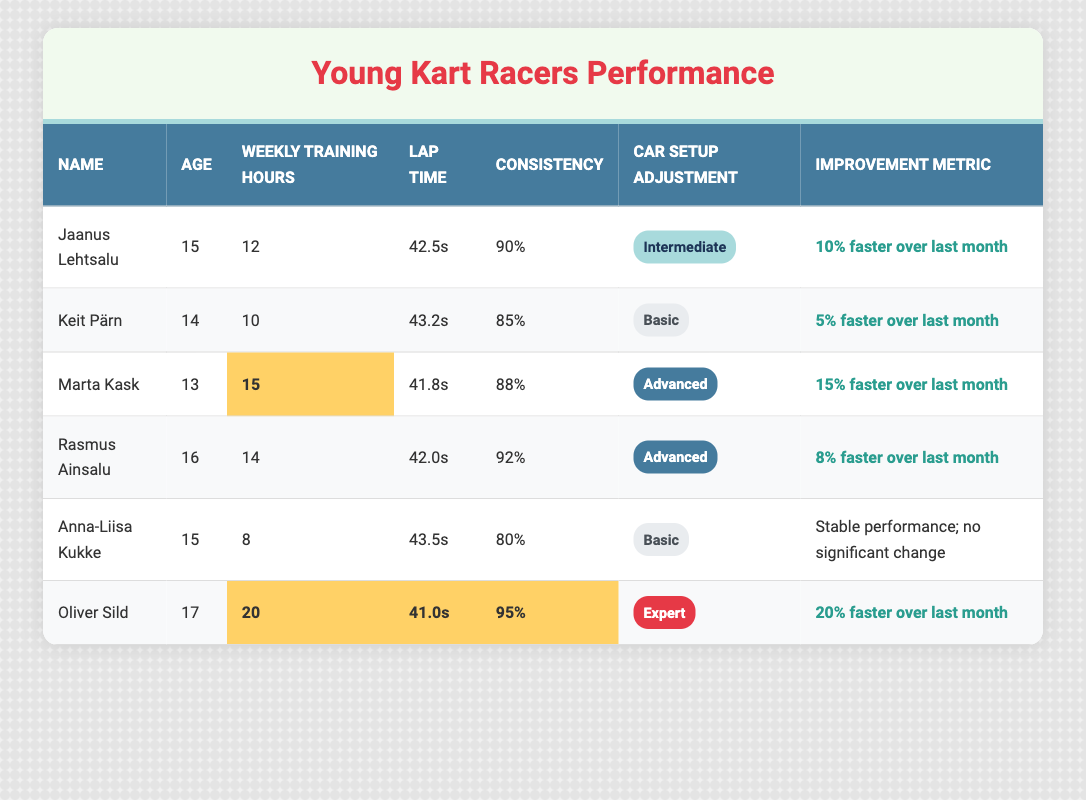What's the lap time of Jaanus Lehtsalu? Looking at the table, Jaanus Lehtsalu's lap time is listed as 42.5 seconds.
Answer: 42.5s Which kart racer has the highest weekly training hours? From the data in the table, Oliver Sild has the highest weekly training hours at 20 hours.
Answer: Oliver Sild How much faster is Marta Kask compared to Keit Pärn? Marta Kask's lap time is 41.8 seconds, while Keit Pärn's is 43.2 seconds. The difference is 43.2 - 41.8 = 1.4 seconds, meaning Marta is 1.4 seconds faster.
Answer: 1.4 seconds Who has the lowest consistency percentage? Anna-Liisa Kukke has the lowest consistency percentage at 80%, as seen in the comparison of the percentages in the table.
Answer: 80% Is Oliver Sild improving faster than Rasmus Ainsalu? Oliver Sild's improvement metric indicates he is 20% faster over last month, while Rasmus Ainsalu's metric shows he is 8% faster. Since 20% is greater than 8%, Oliver is improving faster.
Answer: Yes What is the average lap time of all listed racers? To find the average lap time, we need to sum the lap times: 42.5 + 43.2 + 41.8 + 42.0 + 43.5 + 41.0 = 254 seconds, then divide by the number of racers (6). So, 254 / 6 = 42.33 seconds average lap time.
Answer: 42.33s How many racers have more than 10 weekly training hours? The racers with more than 10 weekly training hours are Jaanus Lehtsalu, Marta Kask, Rasmus Ainsalu, and Oliver Sild - totaling 4 racers.
Answer: 4 What improvements have racers with 'Advanced' car setup adjustments made? Marta Kask has improved by 15%, and Rasmus Ainsalu has improved by 8%. The average of their improvements is (15% + 8%) / 2 = 11.5%.
Answer: 11.5% Who has shown stable performance with no significant change? The table indicates that Anna-Liisa Kukke reported stable performance with no significant change in her improvement metric.
Answer: Anna-Liisa Kukke Which racer has the best consistency percentage? Oliver Sild has the highest consistency percentage at 95%, as indicated in the table.
Answer: 95% 